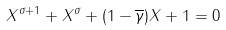<formula> <loc_0><loc_0><loc_500><loc_500>X ^ { \sigma + 1 } + X ^ { \sigma } + ( 1 - \overline { \gamma } ) X + 1 = 0</formula> 